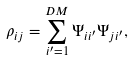<formula> <loc_0><loc_0><loc_500><loc_500>\rho _ { i j } = \sum _ { i ^ { \prime } = 1 } ^ { D M } \Psi _ { i i ^ { \prime } } \Psi _ { j i ^ { \prime } } ,</formula> 